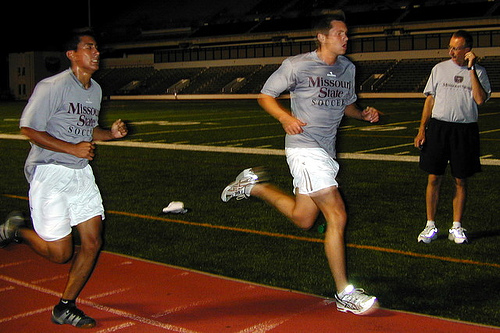<image>
Is there a runner to the left of the runner? Yes. From this viewpoint, the runner is positioned to the left side relative to the runner. 